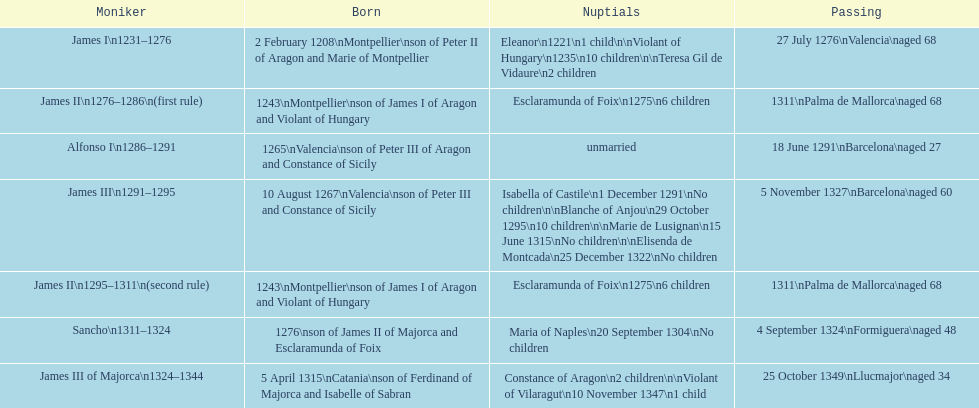What name is above james iii and below james ii? Alfonso I. 